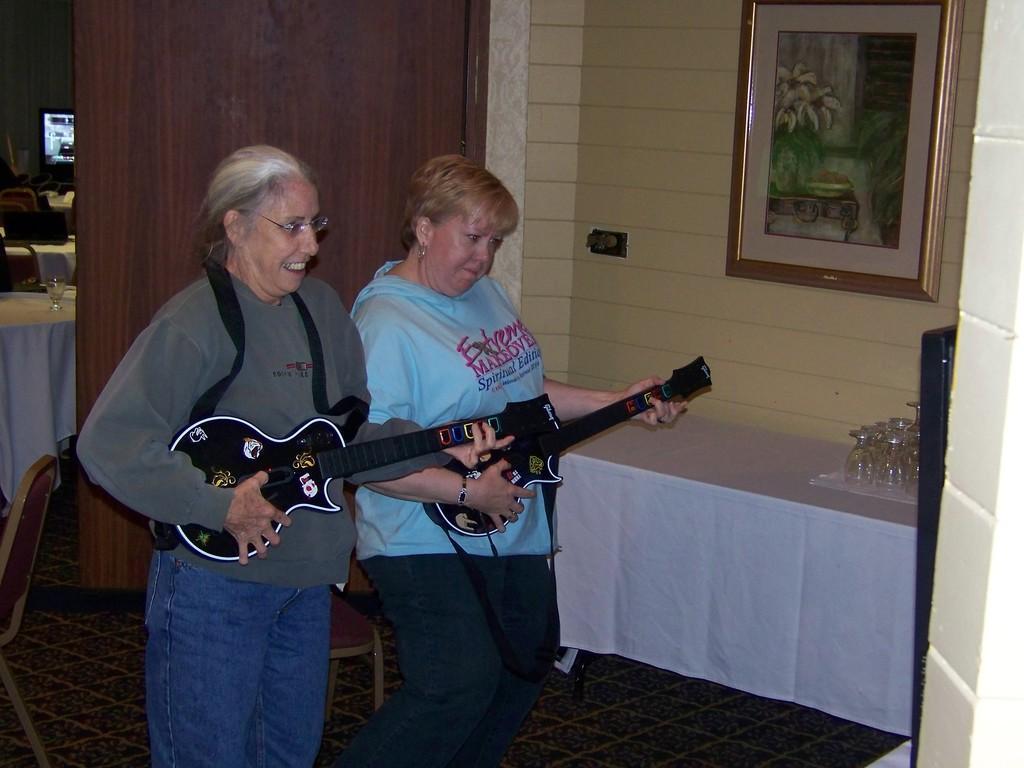Describe this image in one or two sentences. It is a room inside a restaurant there are two people standing with guitar the person who is standing left side is wearing spectacles , to the right side there is a white color table on which glasses are placed above it there is a cream color wall to which a photo frame is attached. 